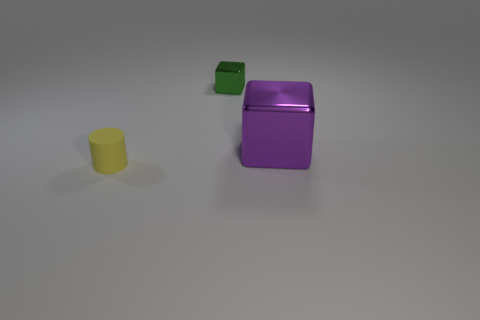Add 3 small green shiny blocks. How many objects exist? 6 Subtract all big cyan matte cylinders. Subtract all yellow cylinders. How many objects are left? 2 Add 2 matte cylinders. How many matte cylinders are left? 3 Add 2 yellow blocks. How many yellow blocks exist? 2 Subtract 0 blue cylinders. How many objects are left? 3 Subtract all cubes. How many objects are left? 1 Subtract 1 cylinders. How many cylinders are left? 0 Subtract all blue blocks. Subtract all blue spheres. How many blocks are left? 2 Subtract all purple cubes. How many green cylinders are left? 0 